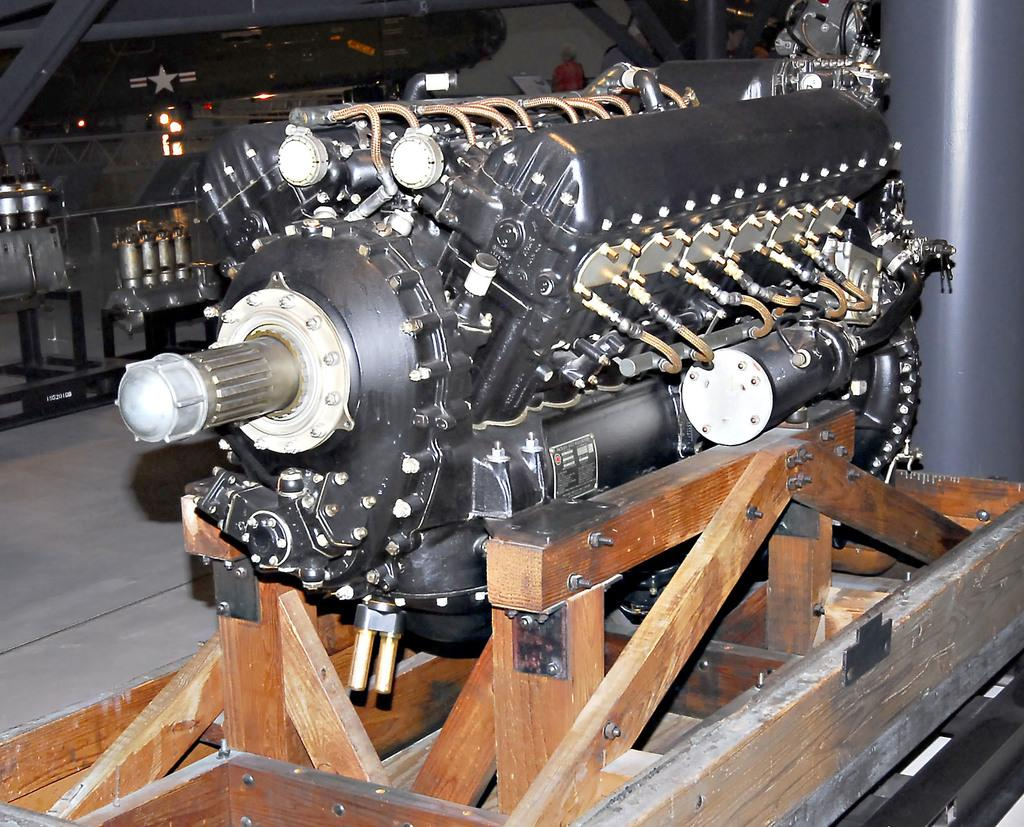What is the main subject of the image? The main subject of the image is an engine. How is the engine positioned in the image? The engine is placed on a wooden block. What type of material is the block that the engine is placed on? The block is made of wood. What can be seen in the background of the image? There are metal objects in the background of the image. What type of vessel is being used to say good-bye in the image? There is no vessel or good-bye being depicted in the image; it features an engine placed on a wooden block with metal objects in the background. 